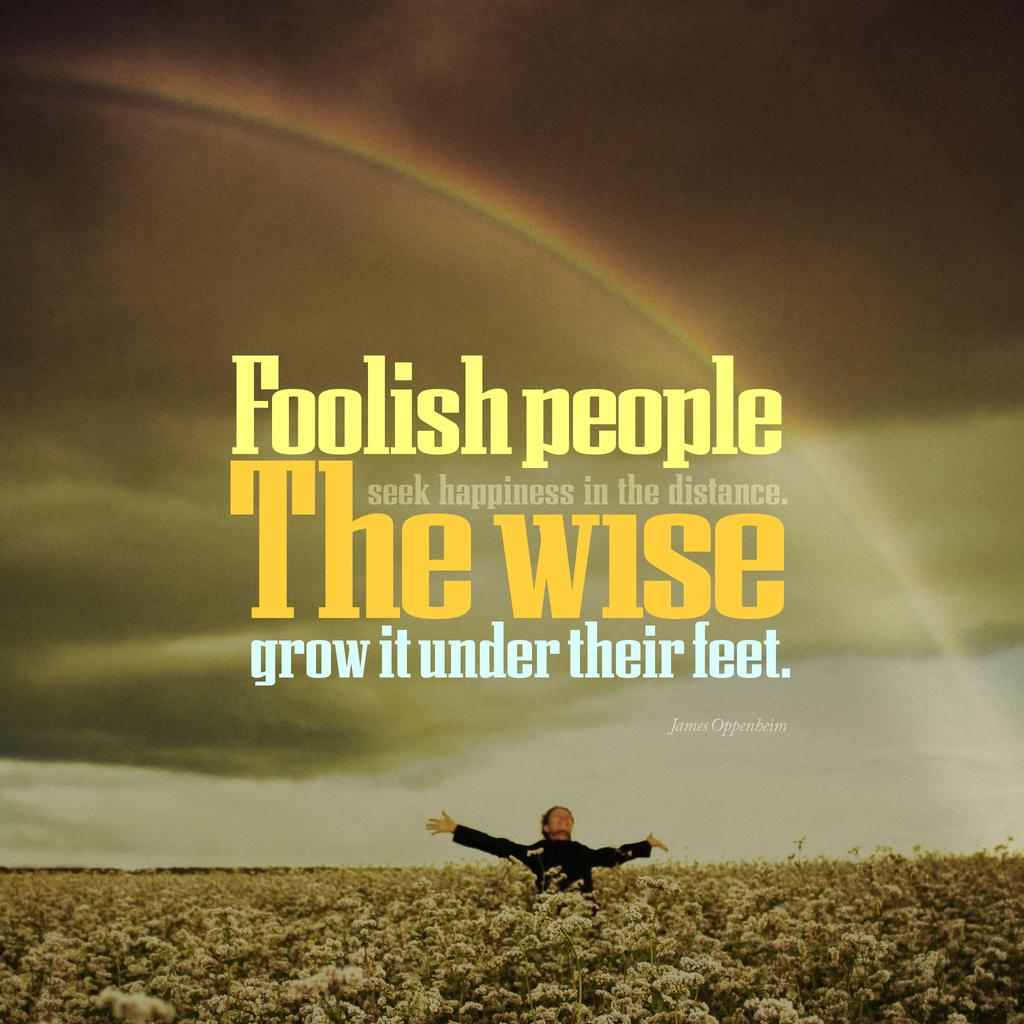Provide a one-sentence caption for the provided image. A poster with the phrase Foolish People seek happiness in the distance. The Wise grow it under their feet. 